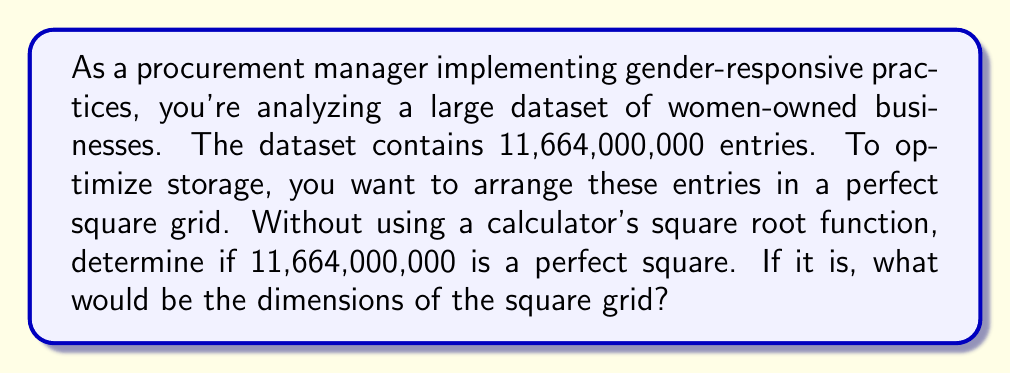Help me with this question. To determine if 11,664,000,000 is a perfect square without using the square root function, we can follow these steps:

1) First, let's consider the prime factorization of 11,664,000,000:

   $11,664,000,000 = 2^{10} \times 3^2 \times 5^4 \times 11^2$

2) For a number to be a perfect square, all its prime factors must have even exponents. In this case, we can see that all exponents are indeed even:
   - 2 has an exponent of 10 (even)
   - 3 has an exponent of 2 (even)
   - 5 has an exponent of 4 (even)
   - 11 has an exponent of 2 (even)

3) Since all exponents are even, 11,664,000,000 is indeed a perfect square.

4) To find the dimensions of the square grid, we need to calculate the square root. We can do this by halving all the exponents in the prime factorization:

   $\sqrt{11,664,000,000} = 2^5 \times 3^1 \times 5^2 \times 11^1$

5) Now let's calculate this:
   $2^5 = 32$
   $3^1 = 3$
   $5^2 = 25$
   $11^1 = 11$

   $32 \times 3 \times 25 \times 11 = 26,400$

Therefore, 11,664,000,000 is a perfect square, and the square grid would have dimensions of 26,400 x 26,400.
Answer: Yes, 11,664,000,000 is a perfect square. The dimensions of the square grid would be 26,400 x 26,400. 